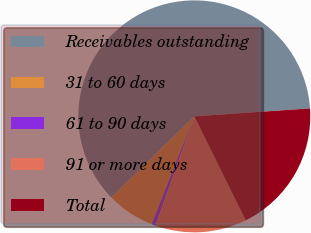Convert chart to OTSL. <chart><loc_0><loc_0><loc_500><loc_500><pie_chart><fcel>Receivables outstanding<fcel>31 to 60 days<fcel>61 to 90 days<fcel>91 or more days<fcel>Total<nl><fcel>61.22%<fcel>6.66%<fcel>0.6%<fcel>12.73%<fcel>18.79%<nl></chart> 